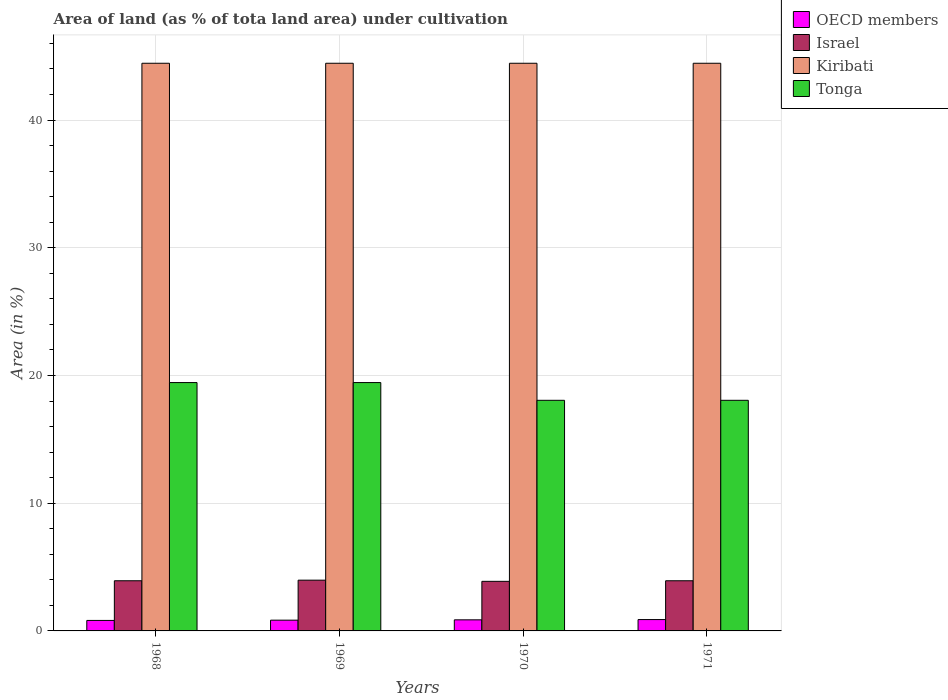How many different coloured bars are there?
Keep it short and to the point. 4. Are the number of bars per tick equal to the number of legend labels?
Your answer should be compact. Yes. How many bars are there on the 1st tick from the left?
Ensure brevity in your answer.  4. How many bars are there on the 1st tick from the right?
Give a very brief answer. 4. What is the label of the 4th group of bars from the left?
Give a very brief answer. 1971. In how many cases, is the number of bars for a given year not equal to the number of legend labels?
Your response must be concise. 0. What is the percentage of land under cultivation in Tonga in 1969?
Offer a terse response. 19.44. Across all years, what is the maximum percentage of land under cultivation in Kiribati?
Your response must be concise. 44.44. Across all years, what is the minimum percentage of land under cultivation in OECD members?
Your answer should be compact. 0.82. In which year was the percentage of land under cultivation in Tonga maximum?
Keep it short and to the point. 1968. In which year was the percentage of land under cultivation in OECD members minimum?
Your response must be concise. 1968. What is the total percentage of land under cultivation in Kiribati in the graph?
Provide a succinct answer. 177.78. What is the difference between the percentage of land under cultivation in Israel in 1970 and that in 1971?
Ensure brevity in your answer.  -0.05. What is the difference between the percentage of land under cultivation in Kiribati in 1968 and the percentage of land under cultivation in OECD members in 1970?
Provide a short and direct response. 43.58. What is the average percentage of land under cultivation in Israel per year?
Your response must be concise. 3.93. In the year 1969, what is the difference between the percentage of land under cultivation in OECD members and percentage of land under cultivation in Tonga?
Keep it short and to the point. -18.6. In how many years, is the percentage of land under cultivation in Kiribati greater than 34 %?
Provide a succinct answer. 4. What is the ratio of the percentage of land under cultivation in Israel in 1968 to that in 1969?
Your answer should be compact. 0.99. What is the difference between the highest and the second highest percentage of land under cultivation in Kiribati?
Your answer should be compact. 0. What is the difference between the highest and the lowest percentage of land under cultivation in OECD members?
Give a very brief answer. 0.07. In how many years, is the percentage of land under cultivation in OECD members greater than the average percentage of land under cultivation in OECD members taken over all years?
Your answer should be very brief. 2. Is the sum of the percentage of land under cultivation in OECD members in 1969 and 1971 greater than the maximum percentage of land under cultivation in Tonga across all years?
Provide a succinct answer. No. What does the 3rd bar from the left in 1969 represents?
Your answer should be compact. Kiribati. What does the 2nd bar from the right in 1968 represents?
Make the answer very short. Kiribati. Is it the case that in every year, the sum of the percentage of land under cultivation in Tonga and percentage of land under cultivation in Kiribati is greater than the percentage of land under cultivation in OECD members?
Ensure brevity in your answer.  Yes. Are all the bars in the graph horizontal?
Offer a terse response. No. How many years are there in the graph?
Make the answer very short. 4. What is the difference between two consecutive major ticks on the Y-axis?
Offer a very short reply. 10. Does the graph contain any zero values?
Give a very brief answer. No. How are the legend labels stacked?
Ensure brevity in your answer.  Vertical. What is the title of the graph?
Provide a short and direct response. Area of land (as % of tota land area) under cultivation. Does "European Union" appear as one of the legend labels in the graph?
Your answer should be very brief. No. What is the label or title of the Y-axis?
Your response must be concise. Area (in %). What is the Area (in %) in OECD members in 1968?
Give a very brief answer. 0.82. What is the Area (in %) in Israel in 1968?
Your answer should be very brief. 3.93. What is the Area (in %) in Kiribati in 1968?
Provide a short and direct response. 44.44. What is the Area (in %) of Tonga in 1968?
Your response must be concise. 19.44. What is the Area (in %) in OECD members in 1969?
Provide a short and direct response. 0.84. What is the Area (in %) of Israel in 1969?
Make the answer very short. 3.97. What is the Area (in %) in Kiribati in 1969?
Your answer should be very brief. 44.44. What is the Area (in %) in Tonga in 1969?
Ensure brevity in your answer.  19.44. What is the Area (in %) of OECD members in 1970?
Your answer should be compact. 0.87. What is the Area (in %) of Israel in 1970?
Provide a succinct answer. 3.88. What is the Area (in %) of Kiribati in 1970?
Your answer should be compact. 44.44. What is the Area (in %) in Tonga in 1970?
Give a very brief answer. 18.06. What is the Area (in %) of OECD members in 1971?
Your answer should be very brief. 0.89. What is the Area (in %) in Israel in 1971?
Give a very brief answer. 3.93. What is the Area (in %) of Kiribati in 1971?
Make the answer very short. 44.44. What is the Area (in %) of Tonga in 1971?
Ensure brevity in your answer.  18.06. Across all years, what is the maximum Area (in %) of OECD members?
Offer a very short reply. 0.89. Across all years, what is the maximum Area (in %) in Israel?
Offer a terse response. 3.97. Across all years, what is the maximum Area (in %) of Kiribati?
Ensure brevity in your answer.  44.44. Across all years, what is the maximum Area (in %) of Tonga?
Offer a very short reply. 19.44. Across all years, what is the minimum Area (in %) in OECD members?
Ensure brevity in your answer.  0.82. Across all years, what is the minimum Area (in %) in Israel?
Provide a short and direct response. 3.88. Across all years, what is the minimum Area (in %) in Kiribati?
Your answer should be very brief. 44.44. Across all years, what is the minimum Area (in %) of Tonga?
Make the answer very short. 18.06. What is the total Area (in %) in OECD members in the graph?
Make the answer very short. 3.42. What is the total Area (in %) in Israel in the graph?
Your answer should be compact. 15.71. What is the total Area (in %) in Kiribati in the graph?
Provide a short and direct response. 177.78. What is the difference between the Area (in %) in OECD members in 1968 and that in 1969?
Offer a very short reply. -0.02. What is the difference between the Area (in %) of Israel in 1968 and that in 1969?
Offer a very short reply. -0.05. What is the difference between the Area (in %) in Kiribati in 1968 and that in 1969?
Keep it short and to the point. 0. What is the difference between the Area (in %) in OECD members in 1968 and that in 1970?
Make the answer very short. -0.05. What is the difference between the Area (in %) in Israel in 1968 and that in 1970?
Provide a short and direct response. 0.05. What is the difference between the Area (in %) of Tonga in 1968 and that in 1970?
Your answer should be compact. 1.39. What is the difference between the Area (in %) in OECD members in 1968 and that in 1971?
Give a very brief answer. -0.07. What is the difference between the Area (in %) in Israel in 1968 and that in 1971?
Keep it short and to the point. 0. What is the difference between the Area (in %) in Kiribati in 1968 and that in 1971?
Offer a terse response. 0. What is the difference between the Area (in %) of Tonga in 1968 and that in 1971?
Your response must be concise. 1.39. What is the difference between the Area (in %) of OECD members in 1969 and that in 1970?
Your response must be concise. -0.03. What is the difference between the Area (in %) of Israel in 1969 and that in 1970?
Your answer should be compact. 0.09. What is the difference between the Area (in %) of Kiribati in 1969 and that in 1970?
Ensure brevity in your answer.  0. What is the difference between the Area (in %) of Tonga in 1969 and that in 1970?
Keep it short and to the point. 1.39. What is the difference between the Area (in %) of OECD members in 1969 and that in 1971?
Your answer should be compact. -0.05. What is the difference between the Area (in %) in Israel in 1969 and that in 1971?
Your answer should be compact. 0.05. What is the difference between the Area (in %) in Kiribati in 1969 and that in 1971?
Your answer should be very brief. 0. What is the difference between the Area (in %) of Tonga in 1969 and that in 1971?
Your response must be concise. 1.39. What is the difference between the Area (in %) of OECD members in 1970 and that in 1971?
Offer a terse response. -0.02. What is the difference between the Area (in %) of Israel in 1970 and that in 1971?
Provide a succinct answer. -0.05. What is the difference between the Area (in %) of Kiribati in 1970 and that in 1971?
Offer a terse response. 0. What is the difference between the Area (in %) in Tonga in 1970 and that in 1971?
Give a very brief answer. 0. What is the difference between the Area (in %) of OECD members in 1968 and the Area (in %) of Israel in 1969?
Your answer should be very brief. -3.15. What is the difference between the Area (in %) of OECD members in 1968 and the Area (in %) of Kiribati in 1969?
Make the answer very short. -43.62. What is the difference between the Area (in %) in OECD members in 1968 and the Area (in %) in Tonga in 1969?
Make the answer very short. -18.62. What is the difference between the Area (in %) in Israel in 1968 and the Area (in %) in Kiribati in 1969?
Your answer should be very brief. -40.52. What is the difference between the Area (in %) in Israel in 1968 and the Area (in %) in Tonga in 1969?
Give a very brief answer. -15.52. What is the difference between the Area (in %) of Kiribati in 1968 and the Area (in %) of Tonga in 1969?
Provide a short and direct response. 25. What is the difference between the Area (in %) of OECD members in 1968 and the Area (in %) of Israel in 1970?
Your answer should be compact. -3.06. What is the difference between the Area (in %) of OECD members in 1968 and the Area (in %) of Kiribati in 1970?
Make the answer very short. -43.62. What is the difference between the Area (in %) of OECD members in 1968 and the Area (in %) of Tonga in 1970?
Offer a terse response. -17.23. What is the difference between the Area (in %) in Israel in 1968 and the Area (in %) in Kiribati in 1970?
Ensure brevity in your answer.  -40.52. What is the difference between the Area (in %) of Israel in 1968 and the Area (in %) of Tonga in 1970?
Offer a terse response. -14.13. What is the difference between the Area (in %) of Kiribati in 1968 and the Area (in %) of Tonga in 1970?
Provide a short and direct response. 26.39. What is the difference between the Area (in %) in OECD members in 1968 and the Area (in %) in Israel in 1971?
Your answer should be very brief. -3.11. What is the difference between the Area (in %) of OECD members in 1968 and the Area (in %) of Kiribati in 1971?
Provide a succinct answer. -43.62. What is the difference between the Area (in %) of OECD members in 1968 and the Area (in %) of Tonga in 1971?
Give a very brief answer. -17.23. What is the difference between the Area (in %) of Israel in 1968 and the Area (in %) of Kiribati in 1971?
Make the answer very short. -40.52. What is the difference between the Area (in %) of Israel in 1968 and the Area (in %) of Tonga in 1971?
Make the answer very short. -14.13. What is the difference between the Area (in %) of Kiribati in 1968 and the Area (in %) of Tonga in 1971?
Your answer should be compact. 26.39. What is the difference between the Area (in %) of OECD members in 1969 and the Area (in %) of Israel in 1970?
Ensure brevity in your answer.  -3.04. What is the difference between the Area (in %) in OECD members in 1969 and the Area (in %) in Kiribati in 1970?
Your response must be concise. -43.6. What is the difference between the Area (in %) of OECD members in 1969 and the Area (in %) of Tonga in 1970?
Your response must be concise. -17.21. What is the difference between the Area (in %) in Israel in 1969 and the Area (in %) in Kiribati in 1970?
Offer a very short reply. -40.47. What is the difference between the Area (in %) of Israel in 1969 and the Area (in %) of Tonga in 1970?
Your response must be concise. -14.08. What is the difference between the Area (in %) in Kiribati in 1969 and the Area (in %) in Tonga in 1970?
Your answer should be very brief. 26.39. What is the difference between the Area (in %) in OECD members in 1969 and the Area (in %) in Israel in 1971?
Your response must be concise. -3.09. What is the difference between the Area (in %) of OECD members in 1969 and the Area (in %) of Kiribati in 1971?
Offer a terse response. -43.6. What is the difference between the Area (in %) of OECD members in 1969 and the Area (in %) of Tonga in 1971?
Offer a very short reply. -17.21. What is the difference between the Area (in %) in Israel in 1969 and the Area (in %) in Kiribati in 1971?
Your response must be concise. -40.47. What is the difference between the Area (in %) in Israel in 1969 and the Area (in %) in Tonga in 1971?
Your answer should be compact. -14.08. What is the difference between the Area (in %) of Kiribati in 1969 and the Area (in %) of Tonga in 1971?
Offer a very short reply. 26.39. What is the difference between the Area (in %) of OECD members in 1970 and the Area (in %) of Israel in 1971?
Provide a short and direct response. -3.06. What is the difference between the Area (in %) in OECD members in 1970 and the Area (in %) in Kiribati in 1971?
Your answer should be very brief. -43.58. What is the difference between the Area (in %) in OECD members in 1970 and the Area (in %) in Tonga in 1971?
Your answer should be compact. -17.19. What is the difference between the Area (in %) in Israel in 1970 and the Area (in %) in Kiribati in 1971?
Your response must be concise. -40.56. What is the difference between the Area (in %) of Israel in 1970 and the Area (in %) of Tonga in 1971?
Your response must be concise. -14.17. What is the difference between the Area (in %) of Kiribati in 1970 and the Area (in %) of Tonga in 1971?
Provide a short and direct response. 26.39. What is the average Area (in %) in OECD members per year?
Offer a terse response. 0.85. What is the average Area (in %) in Israel per year?
Your answer should be very brief. 3.93. What is the average Area (in %) in Kiribati per year?
Provide a short and direct response. 44.44. What is the average Area (in %) of Tonga per year?
Your response must be concise. 18.75. In the year 1968, what is the difference between the Area (in %) of OECD members and Area (in %) of Israel?
Offer a terse response. -3.11. In the year 1968, what is the difference between the Area (in %) in OECD members and Area (in %) in Kiribati?
Offer a very short reply. -43.62. In the year 1968, what is the difference between the Area (in %) of OECD members and Area (in %) of Tonga?
Offer a very short reply. -18.62. In the year 1968, what is the difference between the Area (in %) of Israel and Area (in %) of Kiribati?
Keep it short and to the point. -40.52. In the year 1968, what is the difference between the Area (in %) in Israel and Area (in %) in Tonga?
Give a very brief answer. -15.52. In the year 1969, what is the difference between the Area (in %) of OECD members and Area (in %) of Israel?
Offer a very short reply. -3.13. In the year 1969, what is the difference between the Area (in %) of OECD members and Area (in %) of Kiribati?
Make the answer very short. -43.6. In the year 1969, what is the difference between the Area (in %) of OECD members and Area (in %) of Tonga?
Give a very brief answer. -18.6. In the year 1969, what is the difference between the Area (in %) in Israel and Area (in %) in Kiribati?
Your answer should be very brief. -40.47. In the year 1969, what is the difference between the Area (in %) of Israel and Area (in %) of Tonga?
Offer a terse response. -15.47. In the year 1970, what is the difference between the Area (in %) in OECD members and Area (in %) in Israel?
Your response must be concise. -3.01. In the year 1970, what is the difference between the Area (in %) of OECD members and Area (in %) of Kiribati?
Offer a very short reply. -43.58. In the year 1970, what is the difference between the Area (in %) in OECD members and Area (in %) in Tonga?
Your answer should be compact. -17.19. In the year 1970, what is the difference between the Area (in %) of Israel and Area (in %) of Kiribati?
Give a very brief answer. -40.56. In the year 1970, what is the difference between the Area (in %) in Israel and Area (in %) in Tonga?
Provide a succinct answer. -14.17. In the year 1970, what is the difference between the Area (in %) of Kiribati and Area (in %) of Tonga?
Make the answer very short. 26.39. In the year 1971, what is the difference between the Area (in %) in OECD members and Area (in %) in Israel?
Keep it short and to the point. -3.04. In the year 1971, what is the difference between the Area (in %) of OECD members and Area (in %) of Kiribati?
Provide a succinct answer. -43.56. In the year 1971, what is the difference between the Area (in %) in OECD members and Area (in %) in Tonga?
Your response must be concise. -17.17. In the year 1971, what is the difference between the Area (in %) in Israel and Area (in %) in Kiribati?
Ensure brevity in your answer.  -40.52. In the year 1971, what is the difference between the Area (in %) of Israel and Area (in %) of Tonga?
Make the answer very short. -14.13. In the year 1971, what is the difference between the Area (in %) in Kiribati and Area (in %) in Tonga?
Give a very brief answer. 26.39. What is the ratio of the Area (in %) of OECD members in 1968 to that in 1969?
Give a very brief answer. 0.98. What is the ratio of the Area (in %) in Israel in 1968 to that in 1969?
Your response must be concise. 0.99. What is the ratio of the Area (in %) of Tonga in 1968 to that in 1969?
Your answer should be compact. 1. What is the ratio of the Area (in %) in OECD members in 1968 to that in 1970?
Offer a very short reply. 0.95. What is the ratio of the Area (in %) of Israel in 1968 to that in 1970?
Make the answer very short. 1.01. What is the ratio of the Area (in %) of Tonga in 1968 to that in 1970?
Provide a short and direct response. 1.08. What is the ratio of the Area (in %) in OECD members in 1968 to that in 1971?
Give a very brief answer. 0.93. What is the ratio of the Area (in %) of Kiribati in 1968 to that in 1971?
Keep it short and to the point. 1. What is the ratio of the Area (in %) in OECD members in 1969 to that in 1970?
Offer a terse response. 0.97. What is the ratio of the Area (in %) in Israel in 1969 to that in 1970?
Offer a very short reply. 1.02. What is the ratio of the Area (in %) of Kiribati in 1969 to that in 1970?
Offer a terse response. 1. What is the ratio of the Area (in %) of OECD members in 1969 to that in 1971?
Ensure brevity in your answer.  0.95. What is the ratio of the Area (in %) of Israel in 1969 to that in 1971?
Ensure brevity in your answer.  1.01. What is the ratio of the Area (in %) in Kiribati in 1969 to that in 1971?
Provide a succinct answer. 1. What is the ratio of the Area (in %) of Tonga in 1969 to that in 1971?
Ensure brevity in your answer.  1.08. What is the ratio of the Area (in %) in OECD members in 1970 to that in 1971?
Ensure brevity in your answer.  0.98. What is the ratio of the Area (in %) of Israel in 1970 to that in 1971?
Offer a terse response. 0.99. What is the ratio of the Area (in %) in Tonga in 1970 to that in 1971?
Offer a very short reply. 1. What is the difference between the highest and the second highest Area (in %) of OECD members?
Offer a very short reply. 0.02. What is the difference between the highest and the second highest Area (in %) of Israel?
Provide a short and direct response. 0.05. What is the difference between the highest and the lowest Area (in %) of OECD members?
Provide a short and direct response. 0.07. What is the difference between the highest and the lowest Area (in %) of Israel?
Keep it short and to the point. 0.09. What is the difference between the highest and the lowest Area (in %) in Kiribati?
Keep it short and to the point. 0. What is the difference between the highest and the lowest Area (in %) in Tonga?
Offer a very short reply. 1.39. 